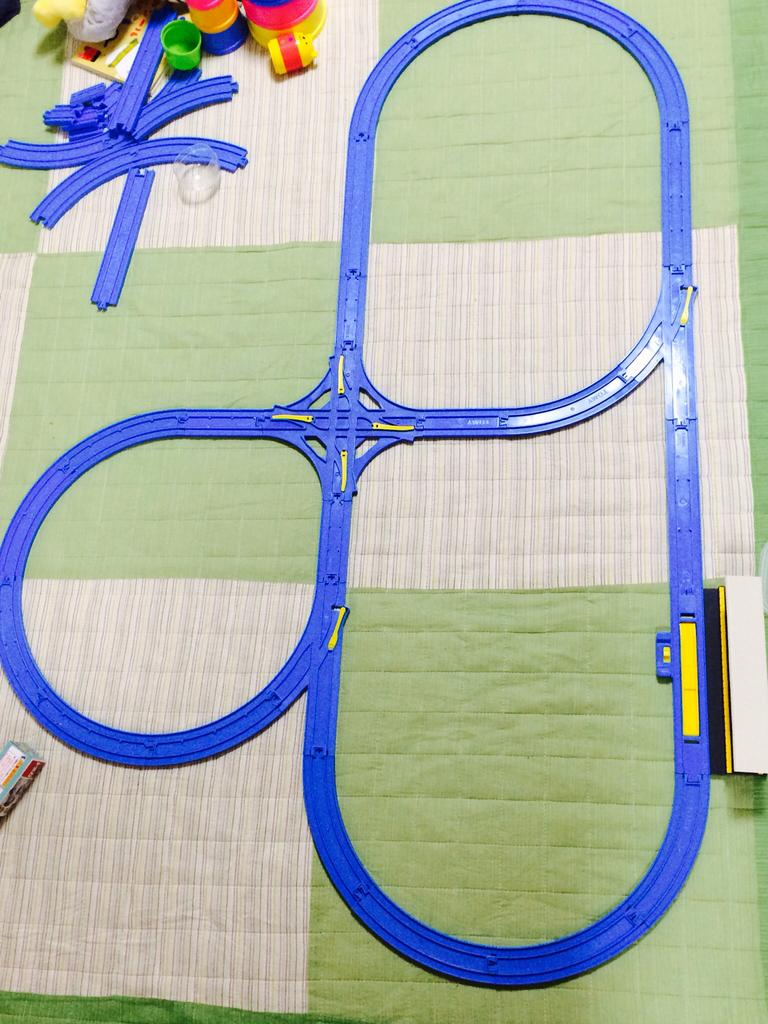What type of railway track is in the image? There is a toy railway track in the image. What color is the railway track? The railway track is blue in color. What other items can be seen in the image besides the railway track? There are toys in the image. What colors are the toys in the image? Some of the toys are pink, yellow, and green in color. What substance is the brother using to fix the railway track in the image? There is no brother present in the image, and no substance is being used to fix the railway track. 